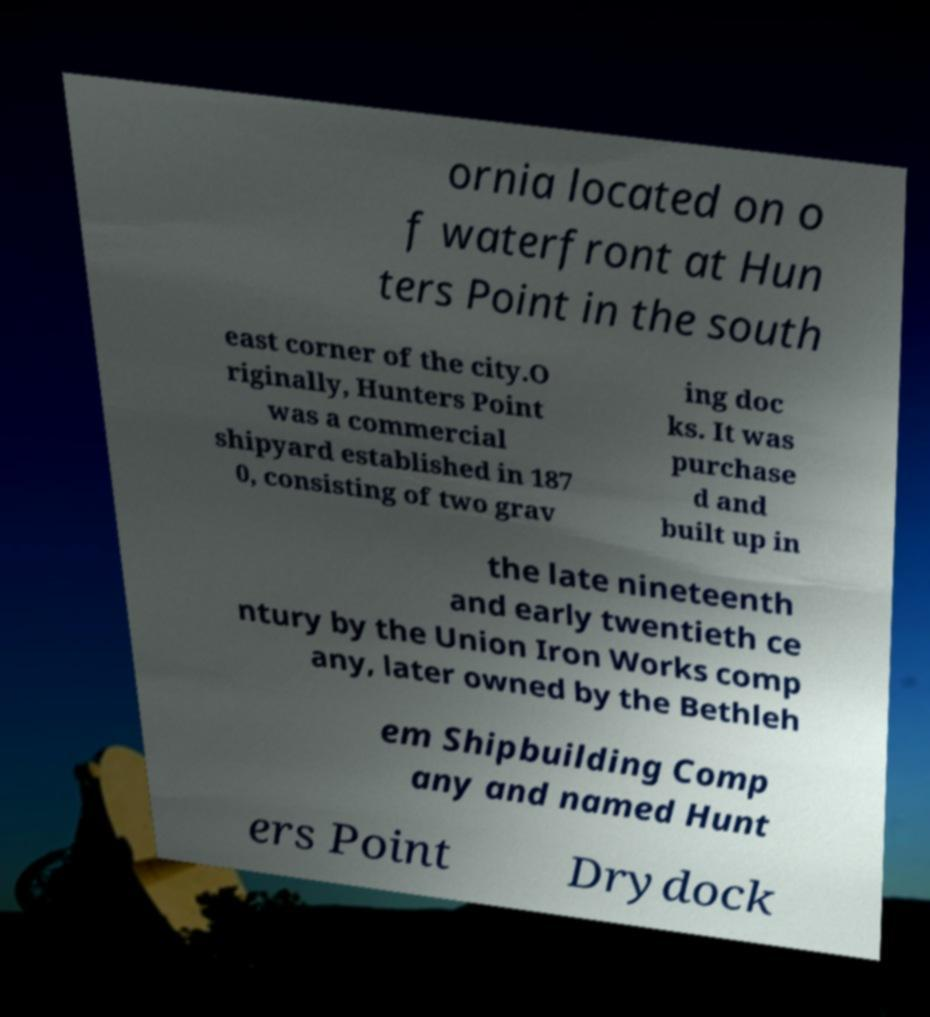For documentation purposes, I need the text within this image transcribed. Could you provide that? ornia located on o f waterfront at Hun ters Point in the south east corner of the city.O riginally, Hunters Point was a commercial shipyard established in 187 0, consisting of two grav ing doc ks. It was purchase d and built up in the late nineteenth and early twentieth ce ntury by the Union Iron Works comp any, later owned by the Bethleh em Shipbuilding Comp any and named Hunt ers Point Drydock 